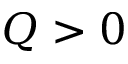Convert formula to latex. <formula><loc_0><loc_0><loc_500><loc_500>Q > 0</formula> 